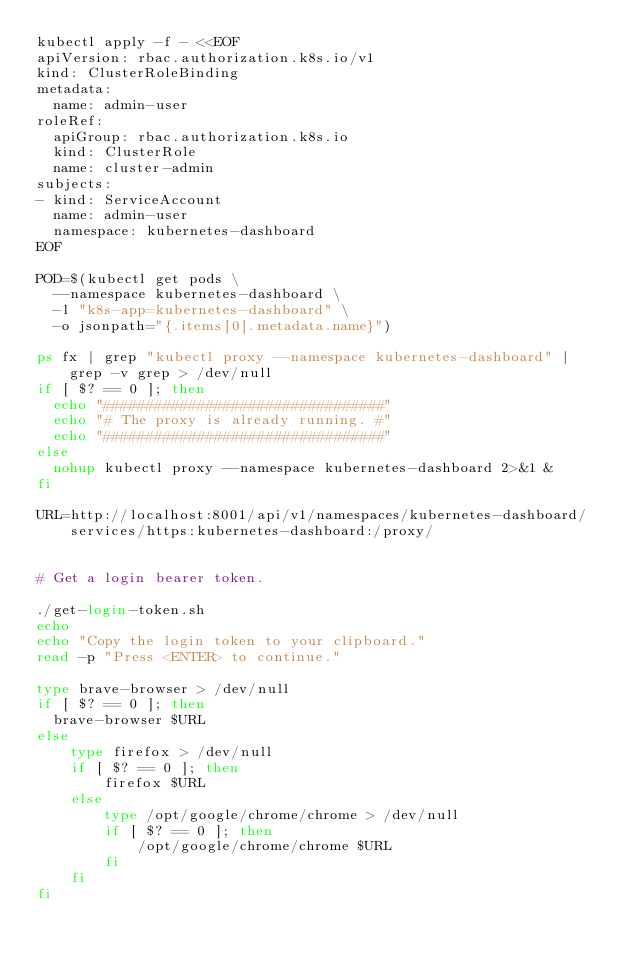Convert code to text. <code><loc_0><loc_0><loc_500><loc_500><_Bash_>kubectl apply -f - <<EOF
apiVersion: rbac.authorization.k8s.io/v1
kind: ClusterRoleBinding
metadata:
  name: admin-user
roleRef:
  apiGroup: rbac.authorization.k8s.io
  kind: ClusterRole
  name: cluster-admin
subjects:
- kind: ServiceAccount
  name: admin-user
  namespace: kubernetes-dashboard
EOF

POD=$(kubectl get pods \
  --namespace kubernetes-dashboard \
  -l "k8s-app=kubernetes-dashboard" \
  -o jsonpath="{.items[0].metadata.name}")

ps fx | grep "kubectl proxy --namespace kubernetes-dashboard" | grep -v grep > /dev/null
if [ $? == 0 ]; then
  echo "#################################"
  echo "# The proxy is already running. #"
  echo "#################################"
else
  nohup kubectl proxy --namespace kubernetes-dashboard 2>&1 &
fi

URL=http://localhost:8001/api/v1/namespaces/kubernetes-dashboard/services/https:kubernetes-dashboard:/proxy/


# Get a login bearer token.

./get-login-token.sh
echo
echo "Copy the login token to your clipboard."
read -p "Press <ENTER> to continue."

type brave-browser > /dev/null
if [ $? == 0 ]; then
  brave-browser $URL
else
    type firefox > /dev/null
    if [ $? == 0 ]; then
        firefox $URL
    else
        type /opt/google/chrome/chrome > /dev/null
        if [ $? == 0 ]; then
            /opt/google/chrome/chrome $URL
        fi
    fi
fi
</code> 